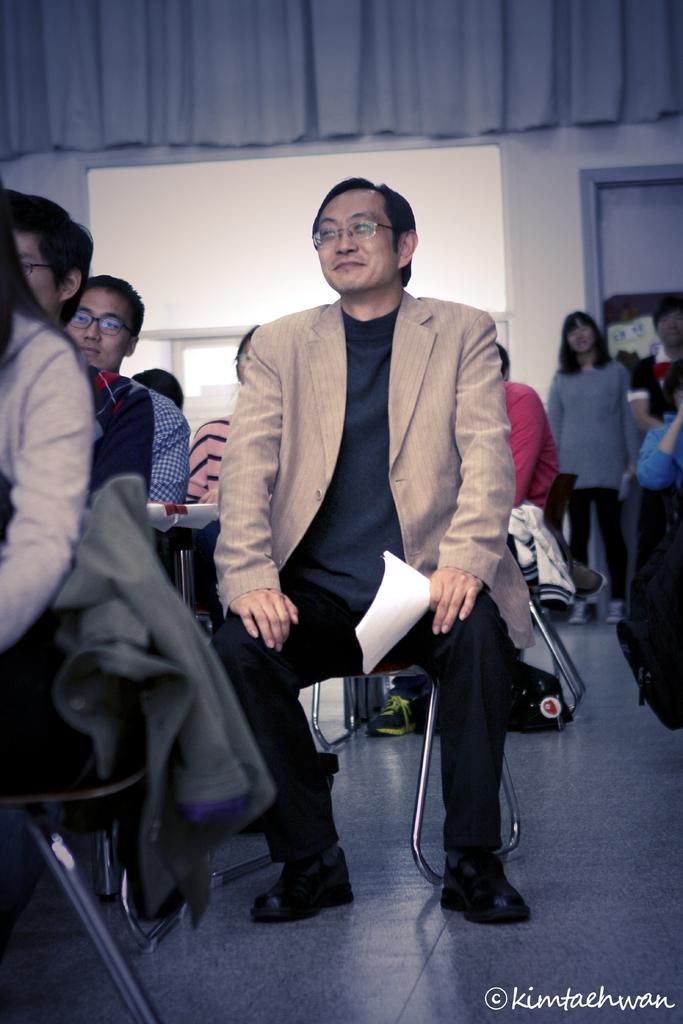Can you describe this image briefly? In the picture we can see some people sitting on the chairs on the floor and in the background, we can see a glass window and just beside it, we can see a door and top of it there is a curtain. 